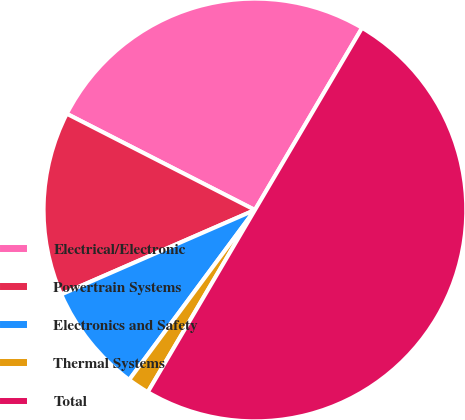<chart> <loc_0><loc_0><loc_500><loc_500><pie_chart><fcel>Electrical/Electronic<fcel>Powertrain Systems<fcel>Electronics and Safety<fcel>Thermal Systems<fcel>Total<nl><fcel>25.94%<fcel>14.07%<fcel>8.31%<fcel>1.68%<fcel>50.0%<nl></chart> 